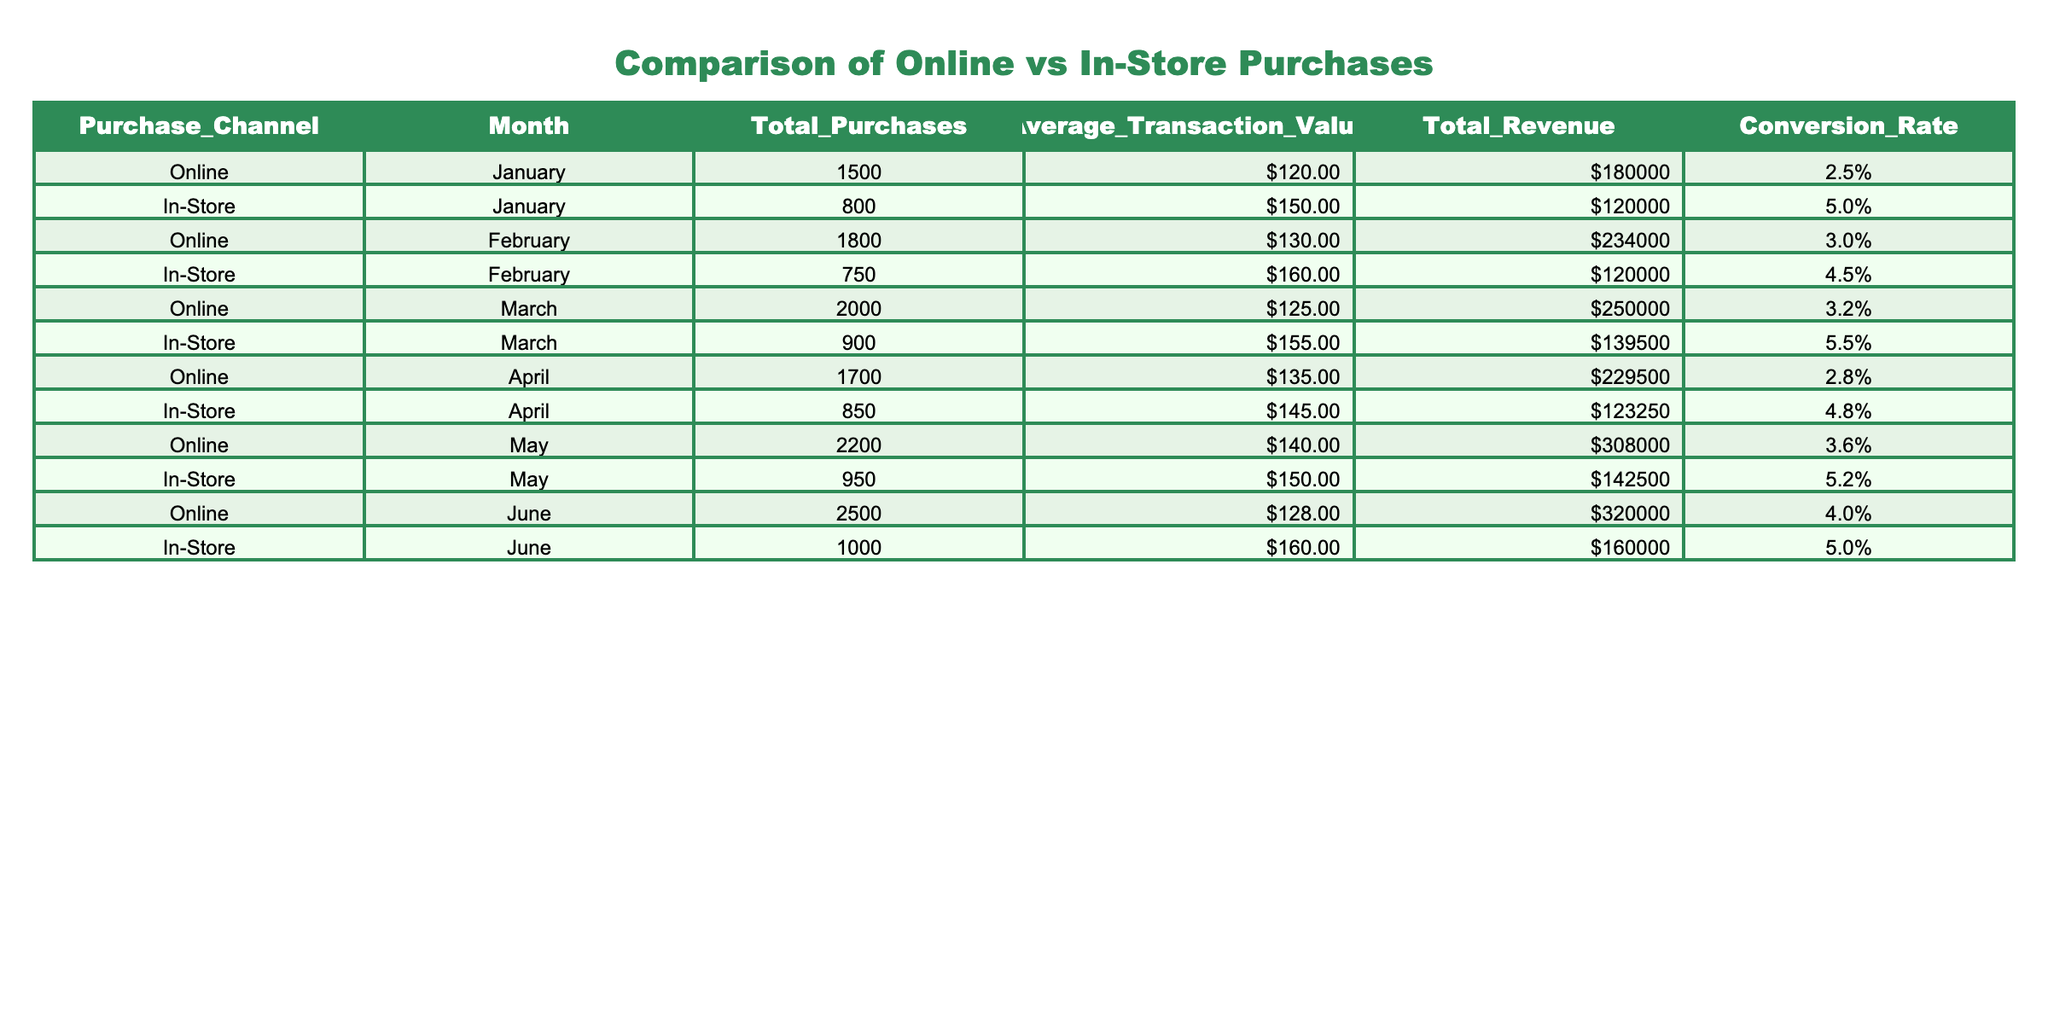What was the total revenue from online purchases in March? The total revenue for online purchases in March is found in the 'Total Revenue' column for the 'Online' row corresponding to March. This value is 250000.
Answer: 250000 What was the average transaction value for in-store purchases in April? The average transaction value for in-store purchases in April is located in the 'Average Transaction Value' column for the 'In-Store' row corresponding to April. This value is 145.00.
Answer: 145 Which month had the highest conversion rate for in-store purchases? To find the month with the highest conversion rate for in-store purchases, we compare the 'Conversion Rate' values for the 'In-Store' purchases across all months. March has the highest conversion rate of 5.5%.
Answer: March What is the difference in total purchases between online and in-store channels in January? For January, the total purchases for online are 1500 and for in-store are 800. The difference is calculated as 1500 - 800, which equals 700.
Answer: 700 Is the conversion rate for online purchases consistently higher than in-store purchases across all months? By examining the 'Conversion Rate' values for both online and in-store purchases month by month, we find that online conversion rates are lower in January, February, April, and May, while they are only slightly higher in June. Therefore, this statement is false.
Answer: No What was the total revenue generated from in-store purchases from January to June? To find the total revenue for in-store purchases from January to June, we sum the 'Total Revenue' values for all months under the in-store category: 120000 + 120000 + 139500 + 123250 + 142500 + 160000 = 804250.
Answer: 804250 Which channel had a higher total revenue in May, and by how much? In May, the total revenue for online purchases is 308000, and for in-store purchases, it is 142500. The difference is calculated as 308000 - 142500 = 165500, indicating online purchases had a higher revenue.
Answer: Online, 165500 What was the average conversion rate for online purchases over the six months? To find the average conversion rate for online purchases, we add the conversion rates for online purchases in all months (2.5 + 3.0 + 3.2 + 2.8 + 3.6 + 4.0) which equals 19.1, then divide by 6 to get the average: 19.1 / 6 = approximately 3.18%.
Answer: 3.18% 